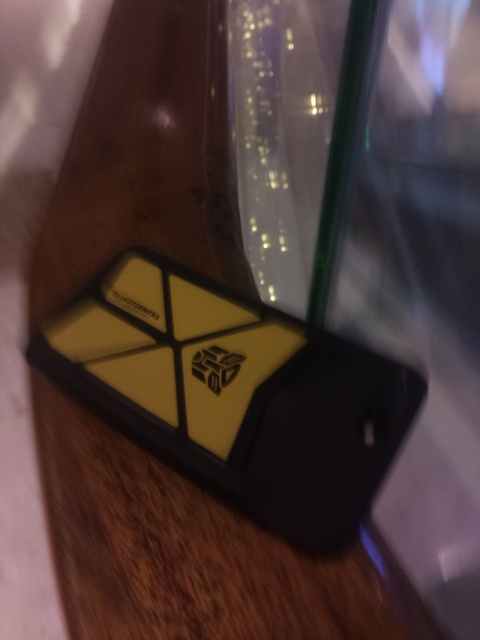What logo is on the phone case in this image? The phone case in the image features a logo commonly associated with the Autobots from the Transformers franchise. 